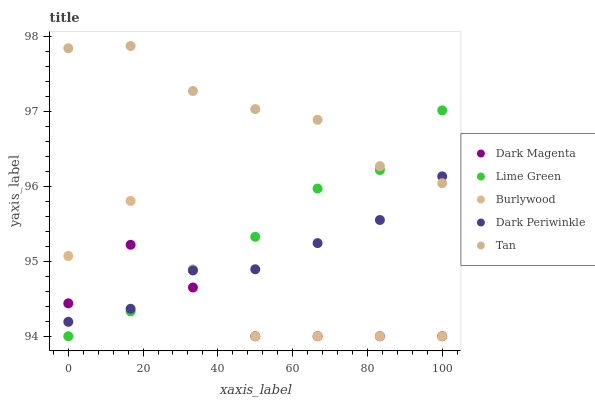Does Dark Magenta have the minimum area under the curve?
Answer yes or no. Yes. Does Tan have the maximum area under the curve?
Answer yes or no. Yes. Does Lime Green have the minimum area under the curve?
Answer yes or no. No. Does Lime Green have the maximum area under the curve?
Answer yes or no. No. Is Dark Periwinkle the smoothest?
Answer yes or no. Yes. Is Burlywood the roughest?
Answer yes or no. Yes. Is Tan the smoothest?
Answer yes or no. No. Is Tan the roughest?
Answer yes or no. No. Does Burlywood have the lowest value?
Answer yes or no. Yes. Does Tan have the lowest value?
Answer yes or no. No. Does Tan have the highest value?
Answer yes or no. Yes. Does Lime Green have the highest value?
Answer yes or no. No. Is Dark Magenta less than Tan?
Answer yes or no. Yes. Is Tan greater than Burlywood?
Answer yes or no. Yes. Does Dark Periwinkle intersect Lime Green?
Answer yes or no. Yes. Is Dark Periwinkle less than Lime Green?
Answer yes or no. No. Is Dark Periwinkle greater than Lime Green?
Answer yes or no. No. Does Dark Magenta intersect Tan?
Answer yes or no. No. 